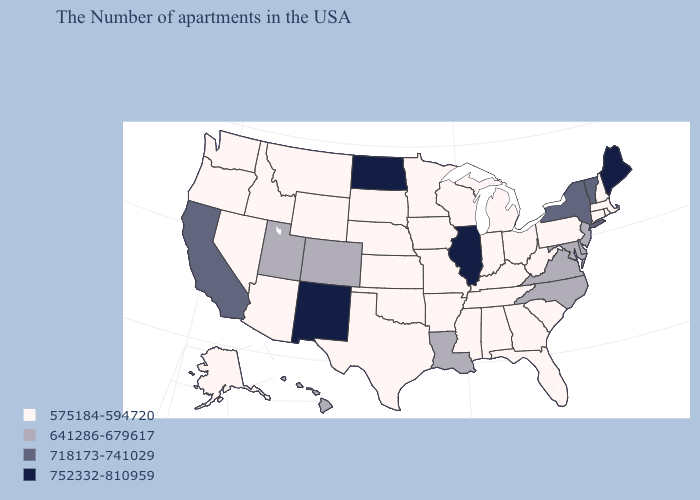Does Florida have the lowest value in the USA?
Write a very short answer. Yes. Does Louisiana have the highest value in the South?
Concise answer only. Yes. What is the value of North Dakota?
Keep it brief. 752332-810959. What is the lowest value in states that border Massachusetts?
Answer briefly. 575184-594720. What is the value of Wisconsin?
Quick response, please. 575184-594720. Does Vermont have the highest value in the Northeast?
Be succinct. No. Which states have the lowest value in the USA?
Short answer required. Massachusetts, Rhode Island, New Hampshire, Connecticut, Pennsylvania, South Carolina, West Virginia, Ohio, Florida, Georgia, Michigan, Kentucky, Indiana, Alabama, Tennessee, Wisconsin, Mississippi, Missouri, Arkansas, Minnesota, Iowa, Kansas, Nebraska, Oklahoma, Texas, South Dakota, Wyoming, Montana, Arizona, Idaho, Nevada, Washington, Oregon, Alaska. What is the value of Michigan?
Quick response, please. 575184-594720. Does Rhode Island have the lowest value in the Northeast?
Quick response, please. Yes. Among the states that border Oklahoma , which have the lowest value?
Quick response, please. Missouri, Arkansas, Kansas, Texas. Does Maine have the highest value in the USA?
Keep it brief. Yes. What is the value of Hawaii?
Answer briefly. 641286-679617. What is the value of Arizona?
Quick response, please. 575184-594720. Does New Mexico have the highest value in the West?
Write a very short answer. Yes. What is the lowest value in the USA?
Quick response, please. 575184-594720. 